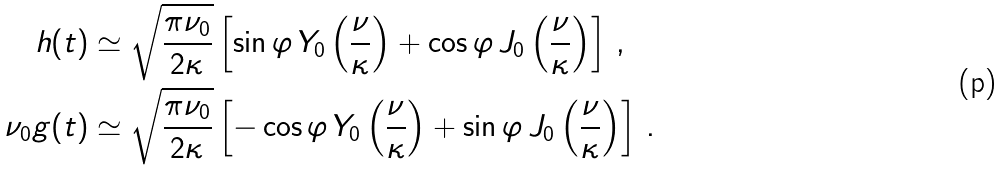<formula> <loc_0><loc_0><loc_500><loc_500>h ( t ) & \simeq \sqrt { \frac { \pi \nu _ { 0 } } { 2 \kappa } } \left [ \sin \varphi \, Y _ { 0 } \left ( \frac { \nu } { \kappa } \right ) + \cos \varphi \, J _ { 0 } \left ( \frac { \nu } { \kappa } \right ) \right ] \, , \\ \nu _ { 0 } g ( t ) & \simeq \sqrt { \frac { \pi \nu _ { 0 } } { 2 \kappa } } \left [ - \cos \varphi \, Y _ { 0 } \left ( \frac { \nu } { \kappa } \right ) + \sin \varphi \, J _ { 0 } \left ( \frac { \nu } { \kappa } \right ) \right ] \, .</formula> 